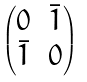<formula> <loc_0><loc_0><loc_500><loc_500>\begin{pmatrix} 0 & \bar { 1 } \\ \bar { 1 } & 0 \end{pmatrix}</formula> 